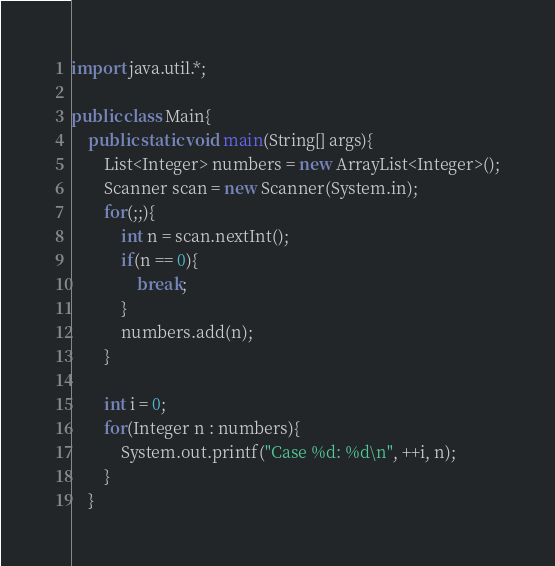Convert code to text. <code><loc_0><loc_0><loc_500><loc_500><_Java_>import java.util.*;

public class Main{
	public static void main(String[] args){
		List<Integer> numbers = new ArrayList<Integer>();
		Scanner scan = new Scanner(System.in);
		for(;;){
			int n = scan.nextInt();
			if(n == 0){
				break;
			}
			numbers.add(n);
		}

		int i = 0;
		for(Integer n : numbers){
			System.out.printf("Case %d: %d\n", ++i, n);
		}
	}</code> 